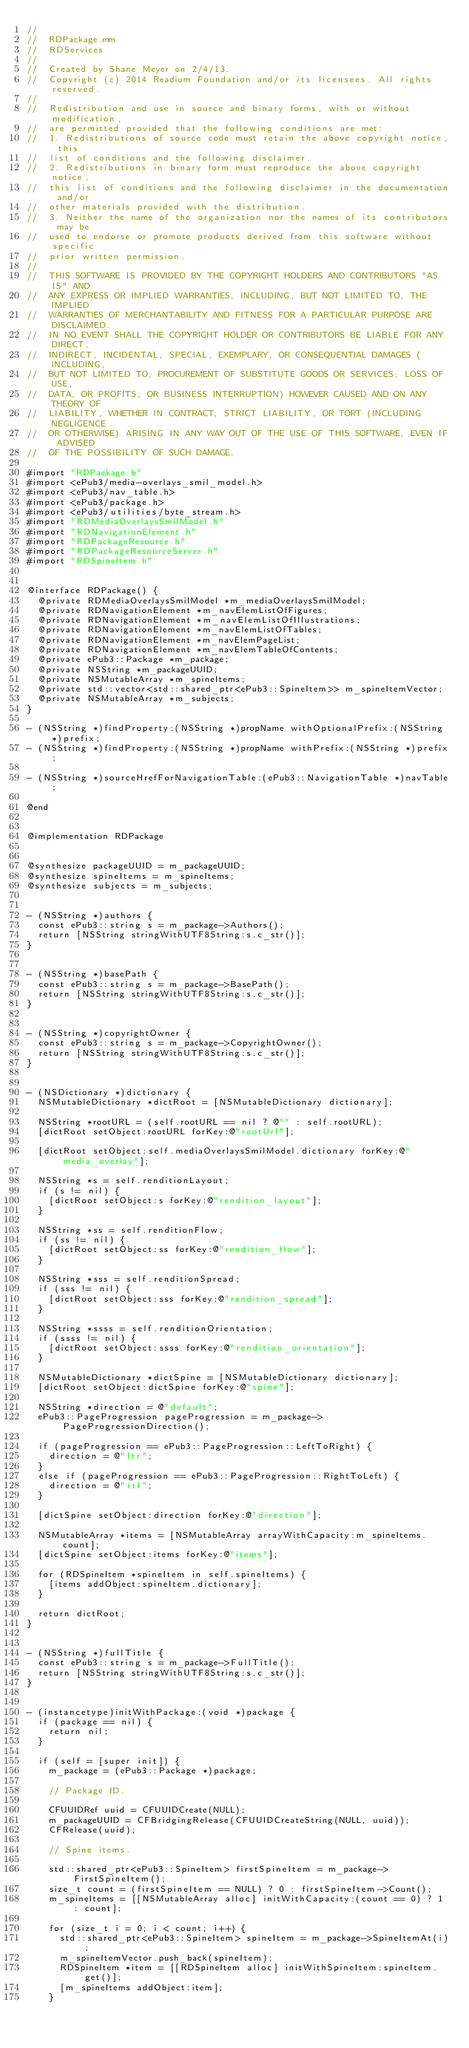<code> <loc_0><loc_0><loc_500><loc_500><_ObjectiveC_>//
//  RDPackage.mm
//  RDServices
//
//  Created by Shane Meyer on 2/4/13.
//  Copyright (c) 2014 Readium Foundation and/or its licensees. All rights reserved.
//  
//  Redistribution and use in source and binary forms, with or without modification, 
//  are permitted provided that the following conditions are met:
//  1. Redistributions of source code must retain the above copyright notice, this 
//  list of conditions and the following disclaimer.
//  2. Redistributions in binary form must reproduce the above copyright notice, 
//  this list of conditions and the following disclaimer in the documentation and/or 
//  other materials provided with the distribution.
//  3. Neither the name of the organization nor the names of its contributors may be 
//  used to endorse or promote products derived from this software without specific 
//  prior written permission.
//  
//  THIS SOFTWARE IS PROVIDED BY THE COPYRIGHT HOLDERS AND CONTRIBUTORS "AS IS" AND 
//  ANY EXPRESS OR IMPLIED WARRANTIES, INCLUDING, BUT NOT LIMITED TO, THE IMPLIED 
//  WARRANTIES OF MERCHANTABILITY AND FITNESS FOR A PARTICULAR PURPOSE ARE DISCLAIMED. 
//  IN NO EVENT SHALL THE COPYRIGHT HOLDER OR CONTRIBUTORS BE LIABLE FOR ANY DIRECT, 
//  INDIRECT, INCIDENTAL, SPECIAL, EXEMPLARY, OR CONSEQUENTIAL DAMAGES (INCLUDING, 
//  BUT NOT LIMITED TO, PROCUREMENT OF SUBSTITUTE GOODS OR SERVICES; LOSS OF USE, 
//  DATA, OR PROFITS; OR BUSINESS INTERRUPTION) HOWEVER CAUSED AND ON ANY THEORY OF 
//  LIABILITY, WHETHER IN CONTRACT, STRICT LIABILITY, OR TORT (INCLUDING NEGLIGENCE 
//  OR OTHERWISE) ARISING IN ANY WAY OUT OF THE USE OF THIS SOFTWARE, EVEN IF ADVISED 
//  OF THE POSSIBILITY OF SUCH DAMAGE.

#import "RDPackage.h"
#import <ePub3/media-overlays_smil_model.h>
#import <ePub3/nav_table.h>
#import <ePub3/package.h>
#import <ePub3/utilities/byte_stream.h>
#import "RDMediaOverlaysSmilModel.h"
#import "RDNavigationElement.h"
#import "RDPackageResource.h"
#import "RDPackageResourceServer.h"
#import "RDSpineItem.h"


@interface RDPackage() {
	@private RDMediaOverlaysSmilModel *m_mediaOverlaysSmilModel;
	@private RDNavigationElement *m_navElemListOfFigures;
	@private RDNavigationElement *m_navElemListOfIllustrations;
	@private RDNavigationElement *m_navElemListOfTables;
	@private RDNavigationElement *m_navElemPageList;
	@private RDNavigationElement *m_navElemTableOfContents;
	@private ePub3::Package *m_package;
	@private NSString *m_packageUUID;
	@private NSMutableArray *m_spineItems;
	@private std::vector<std::shared_ptr<ePub3::SpineItem>> m_spineItemVector;
	@private NSMutableArray *m_subjects;
}

- (NSString *)findProperty:(NSString *)propName withOptionalPrefix:(NSString *)prefix;
- (NSString *)findProperty:(NSString *)propName withPrefix:(NSString *)prefix;

- (NSString *)sourceHrefForNavigationTable:(ePub3::NavigationTable *)navTable;

@end


@implementation RDPackage


@synthesize packageUUID = m_packageUUID;
@synthesize spineItems = m_spineItems;
@synthesize subjects = m_subjects;


- (NSString *)authors {
	const ePub3::string s = m_package->Authors();
	return [NSString stringWithUTF8String:s.c_str()];
}


- (NSString *)basePath {
	const ePub3::string s = m_package->BasePath();
	return [NSString stringWithUTF8String:s.c_str()];
}


- (NSString *)copyrightOwner {
	const ePub3::string s = m_package->CopyrightOwner();
	return [NSString stringWithUTF8String:s.c_str()];
}


- (NSDictionary *)dictionary {
	NSMutableDictionary *dictRoot = [NSMutableDictionary dictionary];

	NSString *rootURL = (self.rootURL == nil ? @"" : self.rootURL);
	[dictRoot setObject:rootURL forKey:@"rootUrl"];

	[dictRoot setObject:self.mediaOverlaysSmilModel.dictionary forKey:@"media_overlay"];

	NSString *s = self.renditionLayout;
	if (s != nil) {
		[dictRoot setObject:s forKey:@"rendition_layout"];
	}

	NSString *ss = self.renditionFlow;
	if (ss != nil) {
		[dictRoot setObject:ss forKey:@"rendition_flow"];
	}

	NSString *sss = self.renditionSpread;
	if (sss != nil) {
		[dictRoot setObject:sss forKey:@"rendition_spread"];
	}

	NSString *ssss = self.renditionOrientation;
	if (ssss != nil) {
		[dictRoot setObject:ssss forKey:@"rendition_orientation"];
	}

	NSMutableDictionary *dictSpine = [NSMutableDictionary dictionary];
	[dictRoot setObject:dictSpine forKey:@"spine"];

	NSString *direction = @"default";
	ePub3::PageProgression pageProgression = m_package->PageProgressionDirection();

	if (pageProgression == ePub3::PageProgression::LeftToRight) {
		direction = @"ltr";
	}
	else if (pageProgression == ePub3::PageProgression::RightToLeft) {
		direction = @"rtl";
	}

	[dictSpine setObject:direction forKey:@"direction"];

	NSMutableArray *items = [NSMutableArray arrayWithCapacity:m_spineItems.count];
	[dictSpine setObject:items forKey:@"items"];

	for (RDSpineItem *spineItem in self.spineItems) {
		[items addObject:spineItem.dictionary];
	}

	return dictRoot;
}


- (NSString *)fullTitle {
	const ePub3::string s = m_package->FullTitle();
	return [NSString stringWithUTF8String:s.c_str()];
}


- (instancetype)initWithPackage:(void *)package {
	if (package == nil) {
		return nil;
	}

	if (self = [super init]) {
		m_package = (ePub3::Package *)package;

		// Package ID.

		CFUUIDRef uuid = CFUUIDCreate(NULL);
		m_packageUUID = CFBridgingRelease(CFUUIDCreateString(NULL, uuid));
		CFRelease(uuid);

		// Spine items.

		std::shared_ptr<ePub3::SpineItem> firstSpineItem = m_package->FirstSpineItem();
		size_t count = (firstSpineItem == NULL) ? 0 : firstSpineItem->Count();
		m_spineItems = [[NSMutableArray alloc] initWithCapacity:(count == 0) ? 1 : count];

		for (size_t i = 0; i < count; i++) {
			std::shared_ptr<ePub3::SpineItem> spineItem = m_package->SpineItemAt(i);
			m_spineItemVector.push_back(spineItem);
			RDSpineItem *item = [[RDSpineItem alloc] initWithSpineItem:spineItem.get()];
			[m_spineItems addObject:item];
		}
</code> 